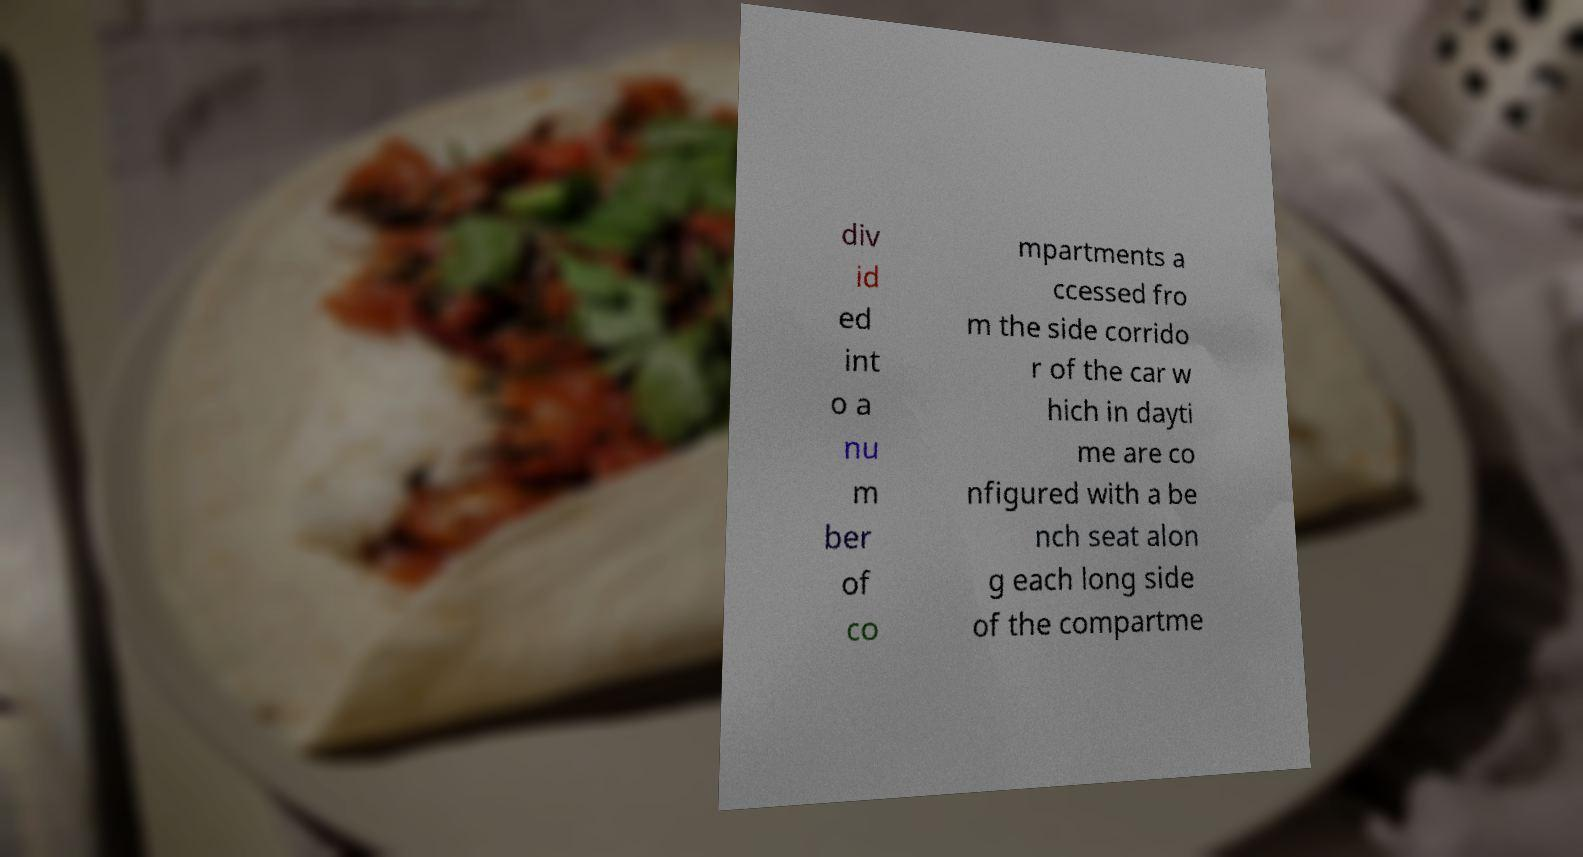Please identify and transcribe the text found in this image. div id ed int o a nu m ber of co mpartments a ccessed fro m the side corrido r of the car w hich in dayti me are co nfigured with a be nch seat alon g each long side of the compartme 